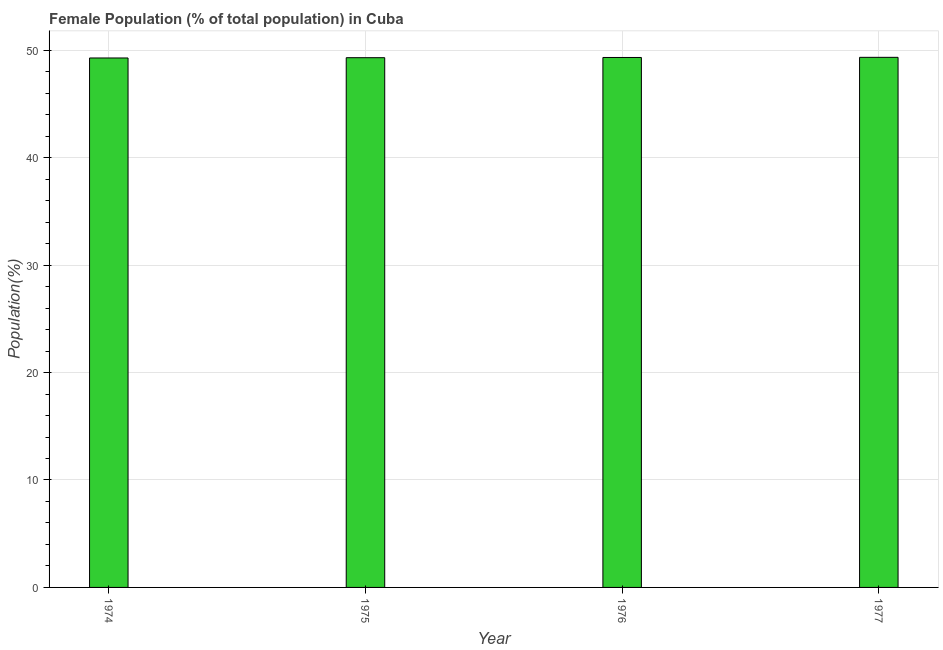Does the graph contain any zero values?
Provide a succinct answer. No. Does the graph contain grids?
Make the answer very short. Yes. What is the title of the graph?
Provide a succinct answer. Female Population (% of total population) in Cuba. What is the label or title of the X-axis?
Ensure brevity in your answer.  Year. What is the label or title of the Y-axis?
Keep it short and to the point. Population(%). What is the female population in 1977?
Your response must be concise. 49.34. Across all years, what is the maximum female population?
Keep it short and to the point. 49.34. Across all years, what is the minimum female population?
Your answer should be very brief. 49.28. In which year was the female population maximum?
Provide a short and direct response. 1977. In which year was the female population minimum?
Offer a terse response. 1974. What is the sum of the female population?
Your answer should be compact. 197.24. What is the difference between the female population in 1974 and 1975?
Provide a succinct answer. -0.03. What is the average female population per year?
Your answer should be very brief. 49.31. What is the median female population?
Offer a very short reply. 49.31. Do a majority of the years between 1976 and 1975 (inclusive) have female population greater than 38 %?
Keep it short and to the point. No. What is the ratio of the female population in 1975 to that in 1976?
Provide a short and direct response. 1. Is the difference between the female population in 1974 and 1977 greater than the difference between any two years?
Ensure brevity in your answer.  Yes. What is the difference between the highest and the second highest female population?
Provide a succinct answer. 0.01. What is the Population(%) of 1974?
Ensure brevity in your answer.  49.28. What is the Population(%) in 1975?
Give a very brief answer. 49.3. What is the Population(%) in 1976?
Your answer should be compact. 49.32. What is the Population(%) in 1977?
Your answer should be compact. 49.34. What is the difference between the Population(%) in 1974 and 1975?
Offer a very short reply. -0.03. What is the difference between the Population(%) in 1974 and 1976?
Provide a short and direct response. -0.05. What is the difference between the Population(%) in 1974 and 1977?
Your answer should be very brief. -0.06. What is the difference between the Population(%) in 1975 and 1976?
Ensure brevity in your answer.  -0.02. What is the difference between the Population(%) in 1975 and 1977?
Ensure brevity in your answer.  -0.03. What is the difference between the Population(%) in 1976 and 1977?
Offer a terse response. -0.01. What is the ratio of the Population(%) in 1974 to that in 1976?
Ensure brevity in your answer.  1. What is the ratio of the Population(%) in 1974 to that in 1977?
Your response must be concise. 1. What is the ratio of the Population(%) in 1975 to that in 1976?
Give a very brief answer. 1. What is the ratio of the Population(%) in 1975 to that in 1977?
Ensure brevity in your answer.  1. What is the ratio of the Population(%) in 1976 to that in 1977?
Your answer should be compact. 1. 